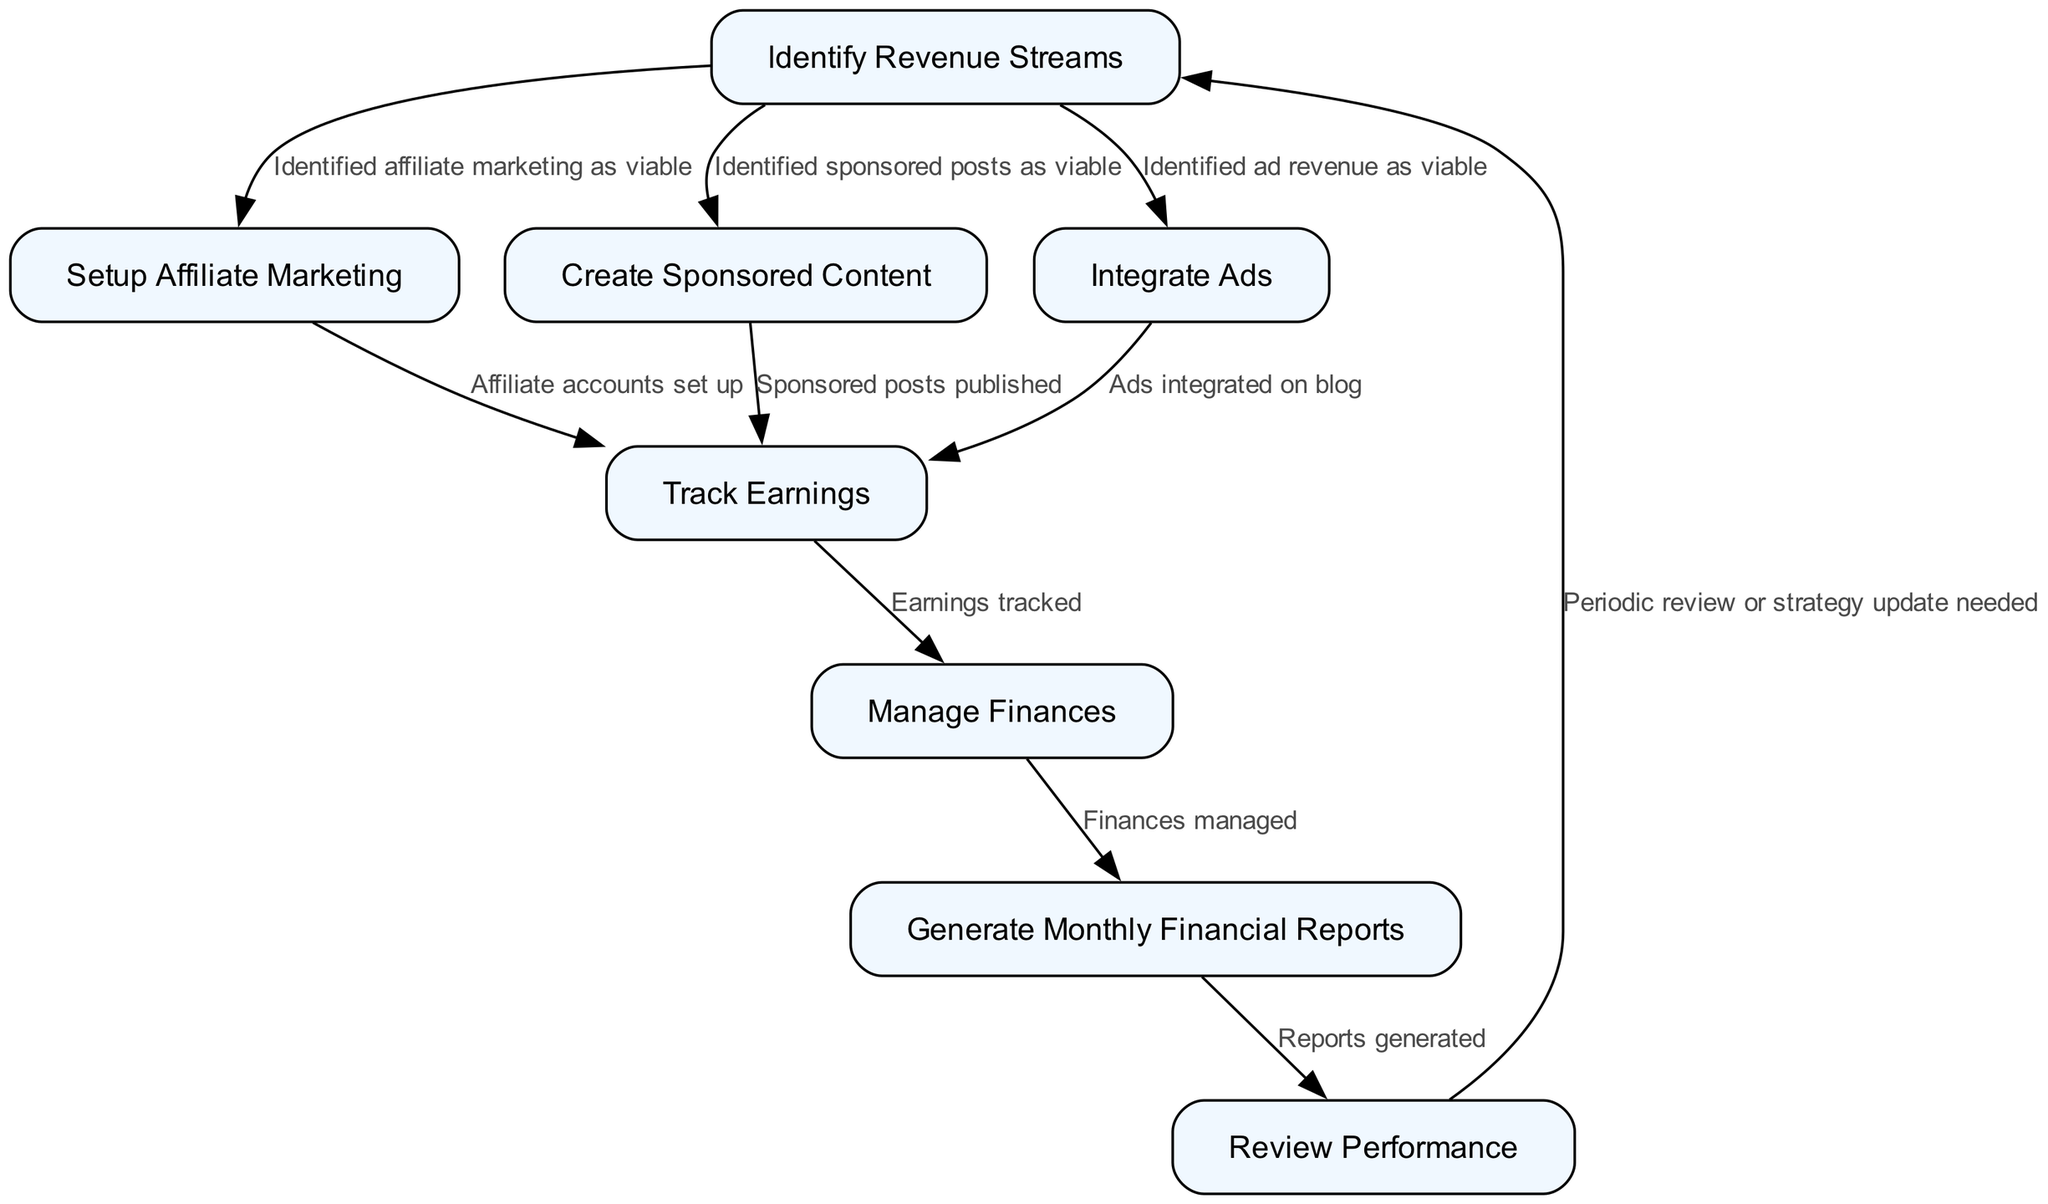What is the first activity in the diagram? The first activity listed in the diagram is "Identify Revenue Streams," as it serves as the starting point for the monetization process.
Answer: Identify Revenue Streams How many total activities are represented in the diagram? There are eight activities total in the diagram, each representing a specific step in managing blog monetization.
Answer: Eight Which activity follows "Integrate Ads"? The activity that follows "Integrate Ads" is "Track Earnings," indicating that once ads are integrated, monitoring earnings becomes the next step.
Answer: Track Earnings What condition leads from "Create Sponsored Content" to "Track Earnings"? The specified condition that leads from "Create Sponsored Content" to "Track Earnings" is that "Sponsored posts published." This means tracking can happen once the sponsored content is available.
Answer: Sponsored posts published If "Manage Finances" is completed, what is the next activity? The next activity after "Manage Finances" is "Generate Monthly Financial Reports," indicating that managing finances is a prerequisite for generating reports.
Answer: Generate Monthly Financial Reports How many transitions are there in total from activity to activity? The diagram contains ten transitions that connect the activities, detailing the flow from one to another based on specific conditions.
Answer: Ten Which activity leads back to "Identify Revenue Streams"? The activity that leads back to "Identify Revenue Streams" is "Review Performance," indicating that performance assessment may prompt a revisit of revenue streams.
Answer: Review Performance What does "Track Earnings" precede in the process? "Track Earnings" precedes "Manage Finances," showing that earnings need to be tracked before finances can be fully managed.
Answer: Manage Finances What condition must be satisfied before setting up affiliate marketing? The condition that must be satisfied before setting up affiliate marketing is that affiliate marketing has been "Identified as viable." This ensures only viable options are pursued.
Answer: Identified as viable 